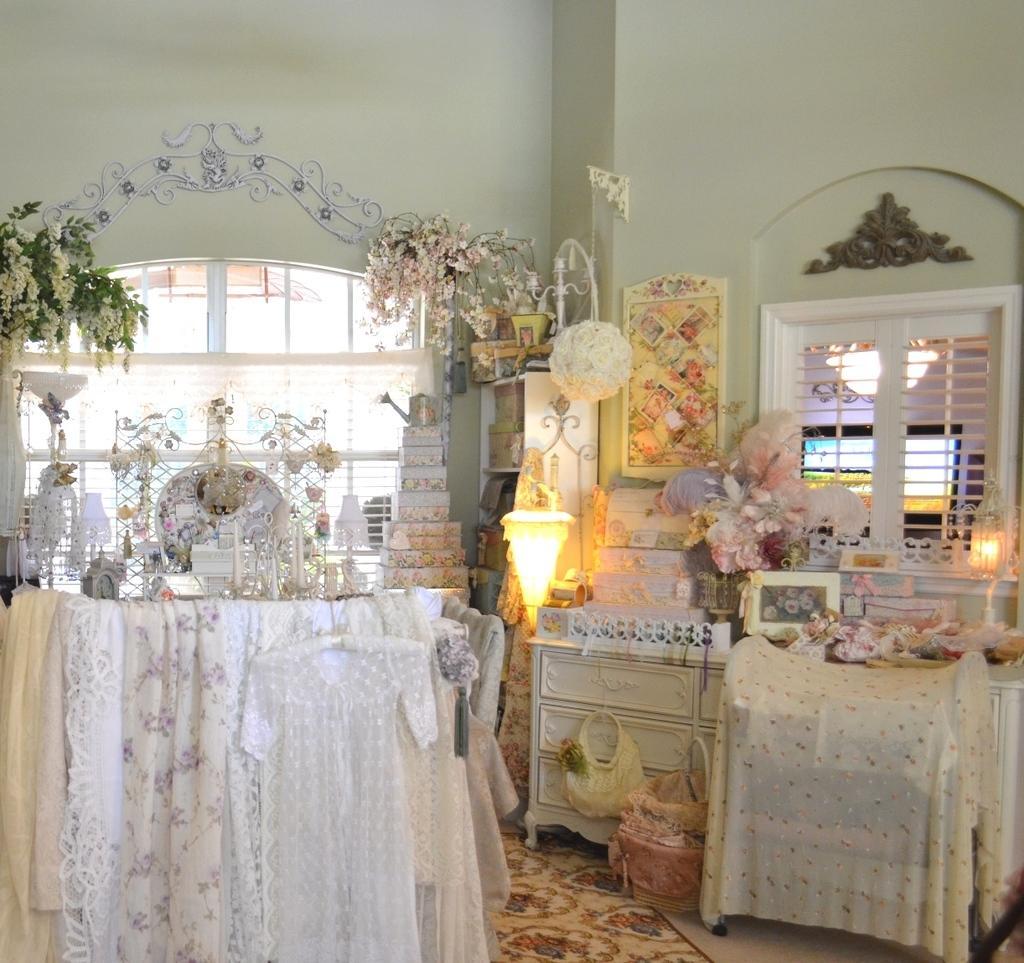Describe this image in one or two sentences. This image is taken indoors. At the bottom of the image there is a floor and there is a mat. In the background there is a wall with a window and grills. On the right side of the image there is a table and a cupboard with many things. In the middle of the image there is a lamp. In this image there are many decorative items, plants and flowers. On the left side of the image there is a table with a tablecloth and many things on it and there is a trouser. 